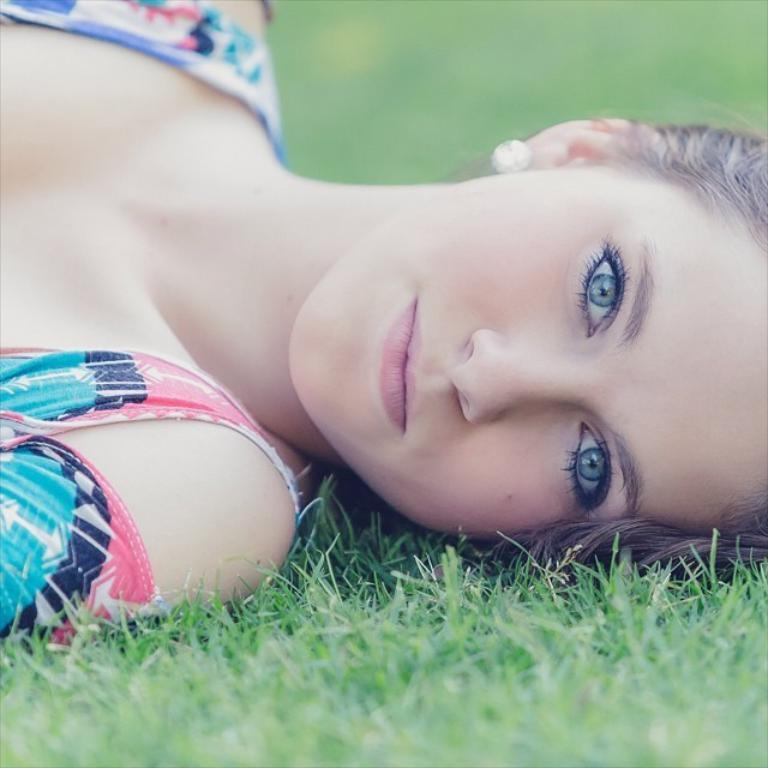Who is the main subject in the image? There is a woman in the image. What is the woman doing in the image? The woman is lying on the grass. What is the woman's facial expression in the image? The woman is smiling. Can you describe the background of the image? The background of the image is blurry. What type of noise can be heard coming from the woman in the image? There is no indication of any noise in the image, as it is a still photograph. 